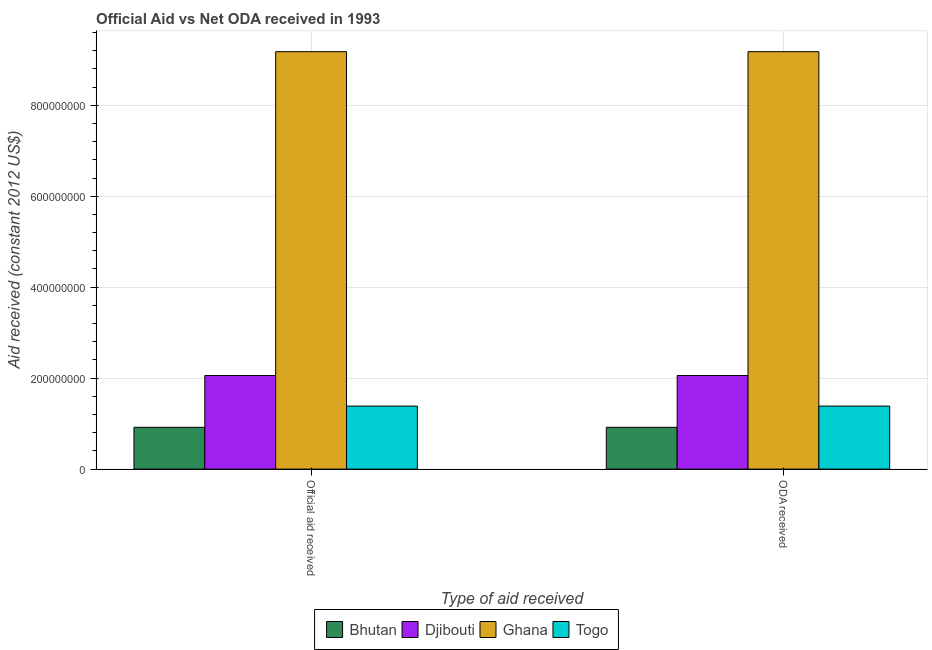How many different coloured bars are there?
Your answer should be compact. 4. How many groups of bars are there?
Provide a succinct answer. 2. How many bars are there on the 1st tick from the left?
Ensure brevity in your answer.  4. How many bars are there on the 2nd tick from the right?
Provide a short and direct response. 4. What is the label of the 2nd group of bars from the left?
Provide a short and direct response. ODA received. What is the oda received in Bhutan?
Keep it short and to the point. 9.19e+07. Across all countries, what is the maximum oda received?
Your response must be concise. 9.18e+08. Across all countries, what is the minimum official aid received?
Your response must be concise. 9.19e+07. In which country was the oda received minimum?
Offer a very short reply. Bhutan. What is the total official aid received in the graph?
Your answer should be very brief. 1.35e+09. What is the difference between the official aid received in Bhutan and that in Djibouti?
Provide a succinct answer. -1.14e+08. What is the difference between the official aid received in Bhutan and the oda received in Ghana?
Ensure brevity in your answer.  -8.26e+08. What is the average official aid received per country?
Provide a short and direct response. 3.38e+08. What is the ratio of the official aid received in Ghana to that in Djibouti?
Offer a terse response. 4.46. Is the oda received in Bhutan less than that in Djibouti?
Make the answer very short. Yes. What does the 2nd bar from the left in Official aid received represents?
Make the answer very short. Djibouti. What does the 3rd bar from the right in ODA received represents?
Provide a succinct answer. Djibouti. Are all the bars in the graph horizontal?
Offer a terse response. No. How many countries are there in the graph?
Keep it short and to the point. 4. What is the difference between two consecutive major ticks on the Y-axis?
Offer a terse response. 2.00e+08. Does the graph contain grids?
Offer a very short reply. Yes. Where does the legend appear in the graph?
Give a very brief answer. Bottom center. How many legend labels are there?
Your response must be concise. 4. What is the title of the graph?
Ensure brevity in your answer.  Official Aid vs Net ODA received in 1993 . What is the label or title of the X-axis?
Provide a succinct answer. Type of aid received. What is the label or title of the Y-axis?
Provide a short and direct response. Aid received (constant 2012 US$). What is the Aid received (constant 2012 US$) of Bhutan in Official aid received?
Offer a very short reply. 9.19e+07. What is the Aid received (constant 2012 US$) in Djibouti in Official aid received?
Offer a very short reply. 2.06e+08. What is the Aid received (constant 2012 US$) of Ghana in Official aid received?
Your answer should be very brief. 9.18e+08. What is the Aid received (constant 2012 US$) in Togo in Official aid received?
Keep it short and to the point. 1.39e+08. What is the Aid received (constant 2012 US$) in Bhutan in ODA received?
Offer a terse response. 9.19e+07. What is the Aid received (constant 2012 US$) of Djibouti in ODA received?
Ensure brevity in your answer.  2.06e+08. What is the Aid received (constant 2012 US$) in Ghana in ODA received?
Offer a very short reply. 9.18e+08. What is the Aid received (constant 2012 US$) in Togo in ODA received?
Provide a succinct answer. 1.39e+08. Across all Type of aid received, what is the maximum Aid received (constant 2012 US$) in Bhutan?
Offer a very short reply. 9.19e+07. Across all Type of aid received, what is the maximum Aid received (constant 2012 US$) of Djibouti?
Offer a very short reply. 2.06e+08. Across all Type of aid received, what is the maximum Aid received (constant 2012 US$) in Ghana?
Give a very brief answer. 9.18e+08. Across all Type of aid received, what is the maximum Aid received (constant 2012 US$) in Togo?
Your answer should be compact. 1.39e+08. Across all Type of aid received, what is the minimum Aid received (constant 2012 US$) of Bhutan?
Offer a very short reply. 9.19e+07. Across all Type of aid received, what is the minimum Aid received (constant 2012 US$) in Djibouti?
Ensure brevity in your answer.  2.06e+08. Across all Type of aid received, what is the minimum Aid received (constant 2012 US$) of Ghana?
Keep it short and to the point. 9.18e+08. Across all Type of aid received, what is the minimum Aid received (constant 2012 US$) in Togo?
Ensure brevity in your answer.  1.39e+08. What is the total Aid received (constant 2012 US$) of Bhutan in the graph?
Make the answer very short. 1.84e+08. What is the total Aid received (constant 2012 US$) of Djibouti in the graph?
Give a very brief answer. 4.12e+08. What is the total Aid received (constant 2012 US$) in Ghana in the graph?
Make the answer very short. 1.84e+09. What is the total Aid received (constant 2012 US$) in Togo in the graph?
Provide a short and direct response. 2.77e+08. What is the difference between the Aid received (constant 2012 US$) of Bhutan in Official aid received and that in ODA received?
Your answer should be very brief. 0. What is the difference between the Aid received (constant 2012 US$) of Togo in Official aid received and that in ODA received?
Provide a short and direct response. 0. What is the difference between the Aid received (constant 2012 US$) in Bhutan in Official aid received and the Aid received (constant 2012 US$) in Djibouti in ODA received?
Keep it short and to the point. -1.14e+08. What is the difference between the Aid received (constant 2012 US$) in Bhutan in Official aid received and the Aid received (constant 2012 US$) in Ghana in ODA received?
Make the answer very short. -8.26e+08. What is the difference between the Aid received (constant 2012 US$) in Bhutan in Official aid received and the Aid received (constant 2012 US$) in Togo in ODA received?
Your answer should be compact. -4.66e+07. What is the difference between the Aid received (constant 2012 US$) of Djibouti in Official aid received and the Aid received (constant 2012 US$) of Ghana in ODA received?
Give a very brief answer. -7.12e+08. What is the difference between the Aid received (constant 2012 US$) of Djibouti in Official aid received and the Aid received (constant 2012 US$) of Togo in ODA received?
Your answer should be very brief. 6.72e+07. What is the difference between the Aid received (constant 2012 US$) of Ghana in Official aid received and the Aid received (constant 2012 US$) of Togo in ODA received?
Give a very brief answer. 7.79e+08. What is the average Aid received (constant 2012 US$) in Bhutan per Type of aid received?
Offer a very short reply. 9.19e+07. What is the average Aid received (constant 2012 US$) in Djibouti per Type of aid received?
Ensure brevity in your answer.  2.06e+08. What is the average Aid received (constant 2012 US$) of Ghana per Type of aid received?
Make the answer very short. 9.18e+08. What is the average Aid received (constant 2012 US$) of Togo per Type of aid received?
Give a very brief answer. 1.39e+08. What is the difference between the Aid received (constant 2012 US$) of Bhutan and Aid received (constant 2012 US$) of Djibouti in Official aid received?
Provide a short and direct response. -1.14e+08. What is the difference between the Aid received (constant 2012 US$) of Bhutan and Aid received (constant 2012 US$) of Ghana in Official aid received?
Your answer should be compact. -8.26e+08. What is the difference between the Aid received (constant 2012 US$) of Bhutan and Aid received (constant 2012 US$) of Togo in Official aid received?
Give a very brief answer. -4.66e+07. What is the difference between the Aid received (constant 2012 US$) in Djibouti and Aid received (constant 2012 US$) in Ghana in Official aid received?
Offer a terse response. -7.12e+08. What is the difference between the Aid received (constant 2012 US$) in Djibouti and Aid received (constant 2012 US$) in Togo in Official aid received?
Give a very brief answer. 6.72e+07. What is the difference between the Aid received (constant 2012 US$) in Ghana and Aid received (constant 2012 US$) in Togo in Official aid received?
Ensure brevity in your answer.  7.79e+08. What is the difference between the Aid received (constant 2012 US$) of Bhutan and Aid received (constant 2012 US$) of Djibouti in ODA received?
Keep it short and to the point. -1.14e+08. What is the difference between the Aid received (constant 2012 US$) of Bhutan and Aid received (constant 2012 US$) of Ghana in ODA received?
Provide a succinct answer. -8.26e+08. What is the difference between the Aid received (constant 2012 US$) in Bhutan and Aid received (constant 2012 US$) in Togo in ODA received?
Make the answer very short. -4.66e+07. What is the difference between the Aid received (constant 2012 US$) of Djibouti and Aid received (constant 2012 US$) of Ghana in ODA received?
Make the answer very short. -7.12e+08. What is the difference between the Aid received (constant 2012 US$) in Djibouti and Aid received (constant 2012 US$) in Togo in ODA received?
Offer a terse response. 6.72e+07. What is the difference between the Aid received (constant 2012 US$) in Ghana and Aid received (constant 2012 US$) in Togo in ODA received?
Your answer should be very brief. 7.79e+08. What is the ratio of the Aid received (constant 2012 US$) of Bhutan in Official aid received to that in ODA received?
Provide a succinct answer. 1. What is the ratio of the Aid received (constant 2012 US$) in Djibouti in Official aid received to that in ODA received?
Your answer should be very brief. 1. What is the ratio of the Aid received (constant 2012 US$) of Togo in Official aid received to that in ODA received?
Make the answer very short. 1. What is the difference between the highest and the second highest Aid received (constant 2012 US$) in Djibouti?
Your response must be concise. 0. What is the difference between the highest and the lowest Aid received (constant 2012 US$) of Bhutan?
Your answer should be very brief. 0. What is the difference between the highest and the lowest Aid received (constant 2012 US$) in Ghana?
Make the answer very short. 0. What is the difference between the highest and the lowest Aid received (constant 2012 US$) in Togo?
Provide a short and direct response. 0. 